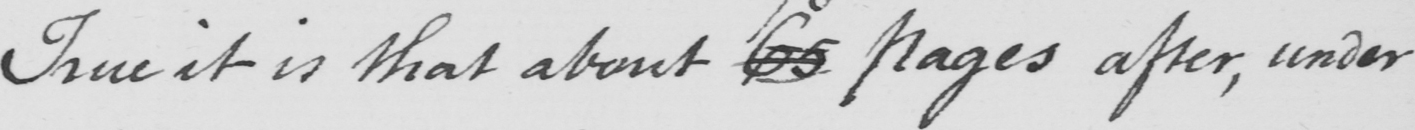What does this handwritten line say? True it is that about 65 pages after, under 